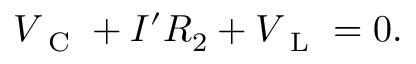<formula> <loc_0><loc_0><loc_500><loc_500>V _ { C } + I ^ { \prime } R _ { 2 } + V _ { L } = 0 .</formula> 